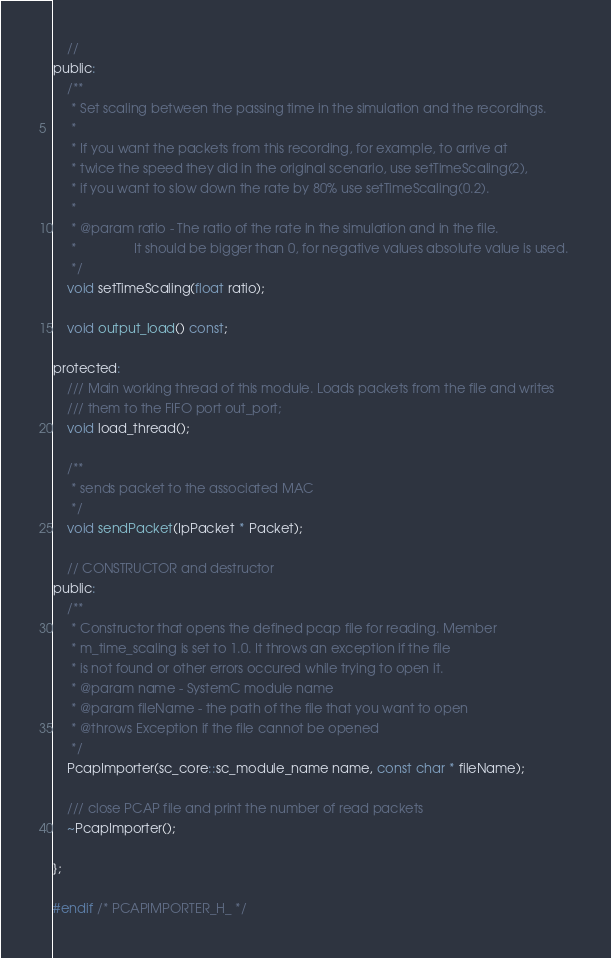Convert code to text. <code><loc_0><loc_0><loc_500><loc_500><_C_>	//
public:
	/**
	 * Set scaling between the passing time in the simulation and the recordings.
	 * 
	 * If you want the packets from this recording, for example, to arrive at
	 * twice the speed they did in the original scenario, use setTimeScaling(2),
	 * if you want to slow down the rate by 80% use setTimeScaling(0.2).
	 * 
	 * @param ratio	- The ratio of the rate in the simulation and in the file.
	 * 				  It should be bigger than 0, for negative values absolute value is used. 
	 */
	void setTimeScaling(float ratio);

	void output_load() const;

protected:
	/// Main working thread of this module. Loads packets from the file and writes
	/// them to the FIFO port out_port;
	void load_thread();

	/**
	 * sends packet to the associated MAC
	 */
	void sendPacket(IpPacket * Packet);

	// CONSTRUCTOR and destructor
public:
	/**
	 * Constructor that opens the defined pcap file for reading. Member
	 * m_time_scaling is set to 1.0. It throws an exception if the file
	 * is not found or other errors occured while trying to open it.
	 * @param name - SystemC module name
	 * @param fileName - the path of the file that you want to open
	 * @throws Exception if the file cannot be opened
	 */
	PcapImporter(sc_core::sc_module_name name, const char * fileName);

	/// close PCAP file and print the number of read packets
	~PcapImporter();

};

#endif /* PCAPIMPORTER_H_ */
</code> 